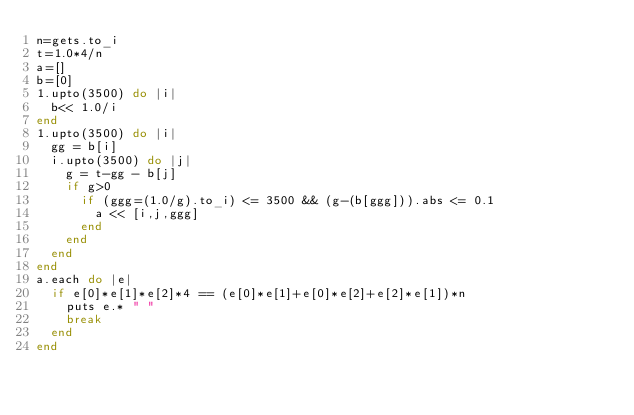Convert code to text. <code><loc_0><loc_0><loc_500><loc_500><_Ruby_>n=gets.to_i
t=1.0*4/n
a=[]
b=[0]
1.upto(3500) do |i|
  b<< 1.0/i
end
1.upto(3500) do |i|
  gg = b[i]
  i.upto(3500) do |j|
    g = t-gg - b[j]
    if g>0
      if (ggg=(1.0/g).to_i) <= 3500 && (g-(b[ggg])).abs <= 0.1
        a << [i,j,ggg]
      end
    end
  end
end
a.each do |e|
  if e[0]*e[1]*e[2]*4 == (e[0]*e[1]+e[0]*e[2]+e[2]*e[1])*n
    puts e.* " "
    break
  end
end

</code> 